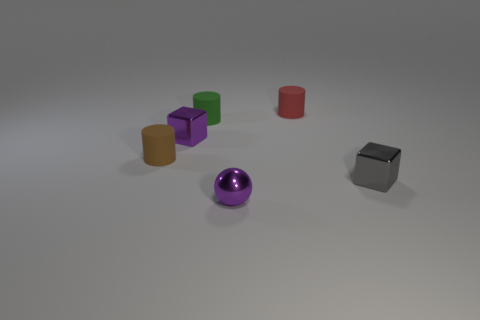Is there a small shiny object of the same color as the ball?
Your response must be concise. Yes. What is the size of the block that is the same color as the small sphere?
Offer a terse response. Small. There is a brown matte object; is it the same shape as the small purple shiny thing behind the tiny gray cube?
Your response must be concise. No. What number of objects are cylinders in front of the red matte object or matte objects that are left of the shiny sphere?
Provide a succinct answer. 2. What is the shape of the object that is the same color as the small metal sphere?
Provide a succinct answer. Cube. What shape is the tiny thing that is behind the tiny green thing?
Keep it short and to the point. Cylinder. Do the metallic thing behind the tiny brown rubber thing and the gray thing have the same shape?
Your response must be concise. Yes. How many things are objects that are left of the red object or matte cylinders?
Offer a terse response. 5. There is another object that is the same shape as the tiny gray object; what color is it?
Ensure brevity in your answer.  Purple. Are there any other things that are the same color as the shiny ball?
Your response must be concise. Yes. 